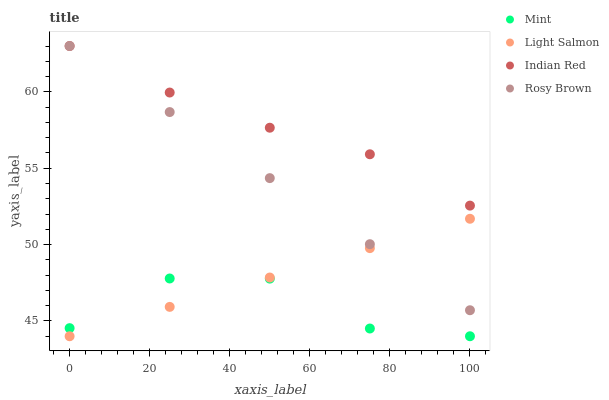Does Mint have the minimum area under the curve?
Answer yes or no. Yes. Does Indian Red have the maximum area under the curve?
Answer yes or no. Yes. Does Rosy Brown have the minimum area under the curve?
Answer yes or no. No. Does Rosy Brown have the maximum area under the curve?
Answer yes or no. No. Is Light Salmon the smoothest?
Answer yes or no. Yes. Is Mint the roughest?
Answer yes or no. Yes. Is Rosy Brown the smoothest?
Answer yes or no. No. Is Rosy Brown the roughest?
Answer yes or no. No. Does Light Salmon have the lowest value?
Answer yes or no. Yes. Does Rosy Brown have the lowest value?
Answer yes or no. No. Does Indian Red have the highest value?
Answer yes or no. Yes. Does Mint have the highest value?
Answer yes or no. No. Is Mint less than Indian Red?
Answer yes or no. Yes. Is Indian Red greater than Light Salmon?
Answer yes or no. Yes. Does Light Salmon intersect Mint?
Answer yes or no. Yes. Is Light Salmon less than Mint?
Answer yes or no. No. Is Light Salmon greater than Mint?
Answer yes or no. No. Does Mint intersect Indian Red?
Answer yes or no. No. 